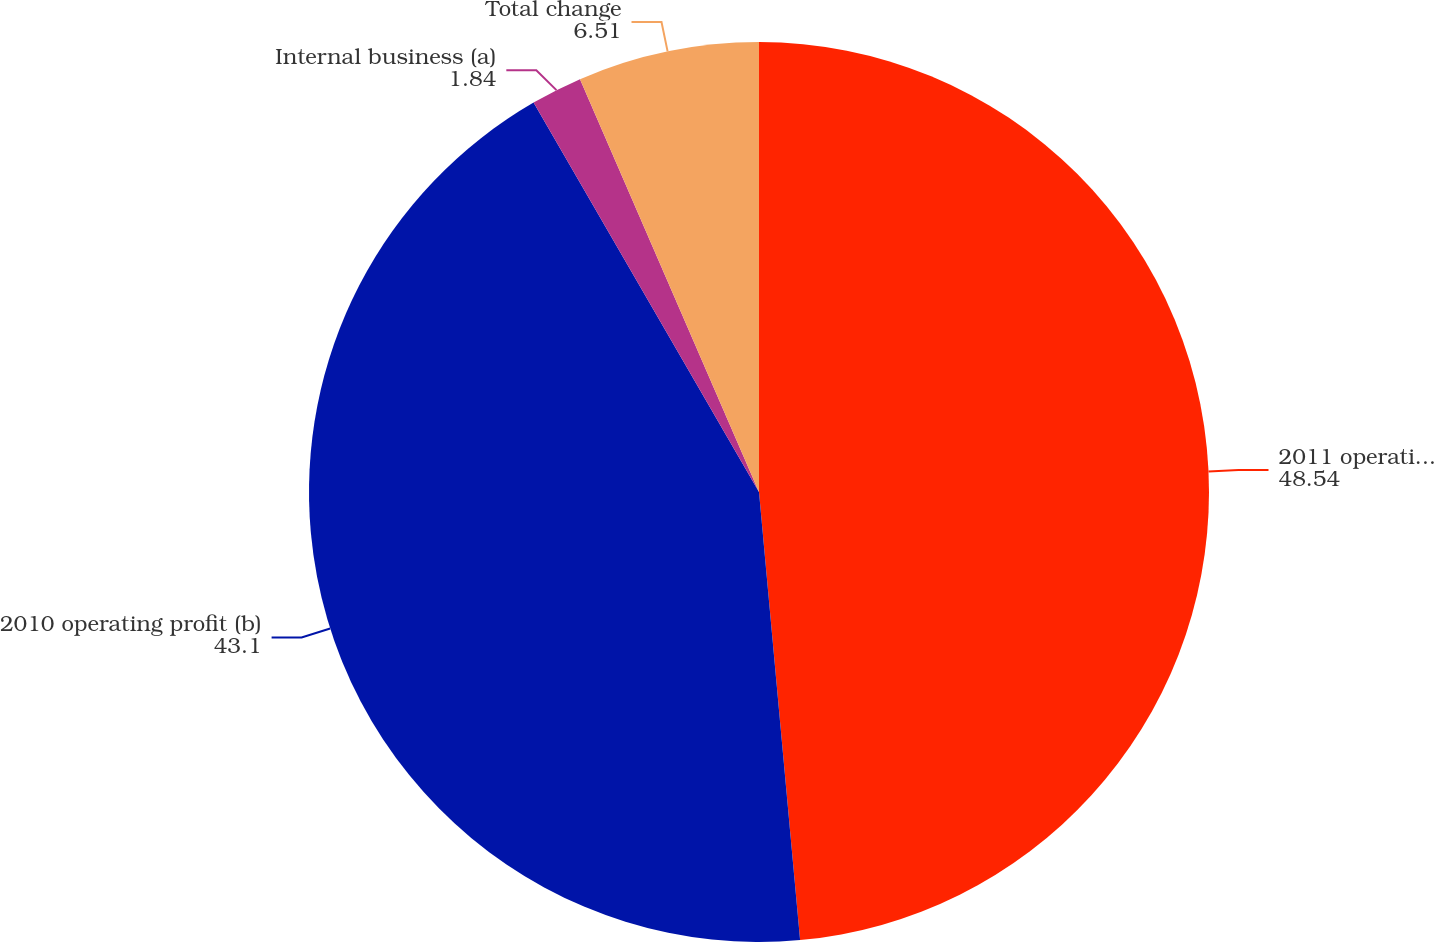<chart> <loc_0><loc_0><loc_500><loc_500><pie_chart><fcel>2011 operating profit (b)<fcel>2010 operating profit (b)<fcel>Internal business (a)<fcel>Total change<nl><fcel>48.54%<fcel>43.1%<fcel>1.84%<fcel>6.51%<nl></chart> 